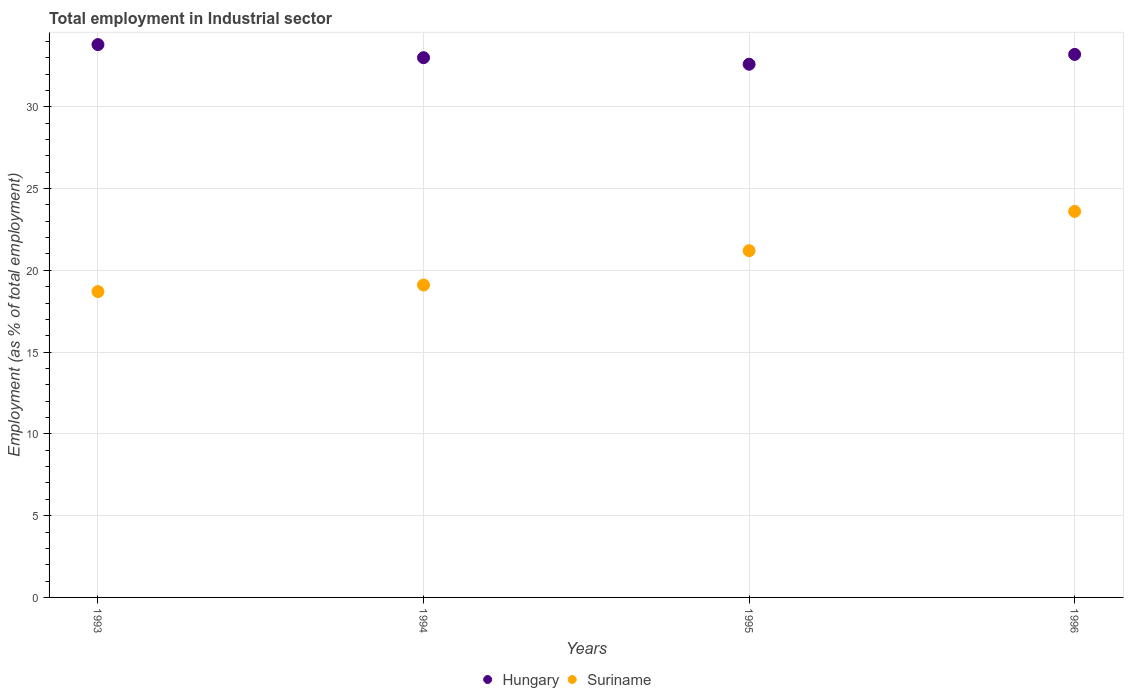How many different coloured dotlines are there?
Offer a very short reply. 2. Is the number of dotlines equal to the number of legend labels?
Your answer should be compact. Yes. What is the employment in industrial sector in Suriname in 1995?
Offer a very short reply. 21.2. Across all years, what is the maximum employment in industrial sector in Hungary?
Keep it short and to the point. 33.8. Across all years, what is the minimum employment in industrial sector in Suriname?
Offer a very short reply. 18.7. In which year was the employment in industrial sector in Suriname minimum?
Your answer should be very brief. 1993. What is the total employment in industrial sector in Hungary in the graph?
Make the answer very short. 132.6. What is the difference between the employment in industrial sector in Suriname in 1994 and that in 1995?
Give a very brief answer. -2.1. What is the difference between the employment in industrial sector in Hungary in 1994 and the employment in industrial sector in Suriname in 1995?
Make the answer very short. 11.8. What is the average employment in industrial sector in Hungary per year?
Provide a short and direct response. 33.15. In the year 1994, what is the difference between the employment in industrial sector in Suriname and employment in industrial sector in Hungary?
Keep it short and to the point. -13.9. In how many years, is the employment in industrial sector in Hungary greater than 25 %?
Offer a terse response. 4. What is the ratio of the employment in industrial sector in Suriname in 1994 to that in 1996?
Make the answer very short. 0.81. Is the difference between the employment in industrial sector in Suriname in 1994 and 1995 greater than the difference between the employment in industrial sector in Hungary in 1994 and 1995?
Offer a very short reply. No. What is the difference between the highest and the second highest employment in industrial sector in Hungary?
Keep it short and to the point. 0.6. What is the difference between the highest and the lowest employment in industrial sector in Suriname?
Your answer should be very brief. 4.9. In how many years, is the employment in industrial sector in Suriname greater than the average employment in industrial sector in Suriname taken over all years?
Ensure brevity in your answer.  2. Is the sum of the employment in industrial sector in Hungary in 1993 and 1996 greater than the maximum employment in industrial sector in Suriname across all years?
Your response must be concise. Yes. Does the employment in industrial sector in Suriname monotonically increase over the years?
Your answer should be very brief. Yes. How many years are there in the graph?
Give a very brief answer. 4. What is the difference between two consecutive major ticks on the Y-axis?
Your answer should be very brief. 5. Are the values on the major ticks of Y-axis written in scientific E-notation?
Ensure brevity in your answer.  No. Where does the legend appear in the graph?
Give a very brief answer. Bottom center. How many legend labels are there?
Keep it short and to the point. 2. How are the legend labels stacked?
Your response must be concise. Horizontal. What is the title of the graph?
Offer a terse response. Total employment in Industrial sector. Does "Costa Rica" appear as one of the legend labels in the graph?
Keep it short and to the point. No. What is the label or title of the Y-axis?
Your response must be concise. Employment (as % of total employment). What is the Employment (as % of total employment) in Hungary in 1993?
Offer a terse response. 33.8. What is the Employment (as % of total employment) in Suriname in 1993?
Your answer should be compact. 18.7. What is the Employment (as % of total employment) of Hungary in 1994?
Your answer should be compact. 33. What is the Employment (as % of total employment) of Suriname in 1994?
Your answer should be very brief. 19.1. What is the Employment (as % of total employment) of Hungary in 1995?
Your answer should be compact. 32.6. What is the Employment (as % of total employment) of Suriname in 1995?
Keep it short and to the point. 21.2. What is the Employment (as % of total employment) of Hungary in 1996?
Provide a succinct answer. 33.2. What is the Employment (as % of total employment) in Suriname in 1996?
Provide a succinct answer. 23.6. Across all years, what is the maximum Employment (as % of total employment) of Hungary?
Provide a succinct answer. 33.8. Across all years, what is the maximum Employment (as % of total employment) of Suriname?
Offer a very short reply. 23.6. Across all years, what is the minimum Employment (as % of total employment) of Hungary?
Offer a very short reply. 32.6. Across all years, what is the minimum Employment (as % of total employment) in Suriname?
Ensure brevity in your answer.  18.7. What is the total Employment (as % of total employment) in Hungary in the graph?
Keep it short and to the point. 132.6. What is the total Employment (as % of total employment) of Suriname in the graph?
Ensure brevity in your answer.  82.6. What is the difference between the Employment (as % of total employment) of Hungary in 1993 and that in 1995?
Your response must be concise. 1.2. What is the difference between the Employment (as % of total employment) of Hungary in 1993 and that in 1996?
Your answer should be compact. 0.6. What is the difference between the Employment (as % of total employment) of Suriname in 1993 and that in 1996?
Ensure brevity in your answer.  -4.9. What is the difference between the Employment (as % of total employment) in Suriname in 1994 and that in 1995?
Keep it short and to the point. -2.1. What is the difference between the Employment (as % of total employment) in Suriname in 1994 and that in 1996?
Ensure brevity in your answer.  -4.5. What is the difference between the Employment (as % of total employment) in Hungary in 1993 and the Employment (as % of total employment) in Suriname in 1994?
Offer a terse response. 14.7. What is the difference between the Employment (as % of total employment) of Hungary in 1993 and the Employment (as % of total employment) of Suriname in 1995?
Your answer should be compact. 12.6. What is the difference between the Employment (as % of total employment) of Hungary in 1993 and the Employment (as % of total employment) of Suriname in 1996?
Provide a succinct answer. 10.2. What is the average Employment (as % of total employment) in Hungary per year?
Keep it short and to the point. 33.15. What is the average Employment (as % of total employment) of Suriname per year?
Ensure brevity in your answer.  20.65. In the year 1993, what is the difference between the Employment (as % of total employment) of Hungary and Employment (as % of total employment) of Suriname?
Ensure brevity in your answer.  15.1. In the year 1994, what is the difference between the Employment (as % of total employment) in Hungary and Employment (as % of total employment) in Suriname?
Make the answer very short. 13.9. What is the ratio of the Employment (as % of total employment) in Hungary in 1993 to that in 1994?
Ensure brevity in your answer.  1.02. What is the ratio of the Employment (as % of total employment) of Suriname in 1993 to that in 1994?
Give a very brief answer. 0.98. What is the ratio of the Employment (as % of total employment) in Hungary in 1993 to that in 1995?
Offer a terse response. 1.04. What is the ratio of the Employment (as % of total employment) in Suriname in 1993 to that in 1995?
Offer a terse response. 0.88. What is the ratio of the Employment (as % of total employment) of Hungary in 1993 to that in 1996?
Your response must be concise. 1.02. What is the ratio of the Employment (as % of total employment) of Suriname in 1993 to that in 1996?
Provide a succinct answer. 0.79. What is the ratio of the Employment (as % of total employment) of Hungary in 1994 to that in 1995?
Offer a terse response. 1.01. What is the ratio of the Employment (as % of total employment) of Suriname in 1994 to that in 1995?
Offer a very short reply. 0.9. What is the ratio of the Employment (as % of total employment) of Suriname in 1994 to that in 1996?
Offer a very short reply. 0.81. What is the ratio of the Employment (as % of total employment) of Hungary in 1995 to that in 1996?
Keep it short and to the point. 0.98. What is the ratio of the Employment (as % of total employment) in Suriname in 1995 to that in 1996?
Keep it short and to the point. 0.9. What is the difference between the highest and the lowest Employment (as % of total employment) in Hungary?
Make the answer very short. 1.2. 